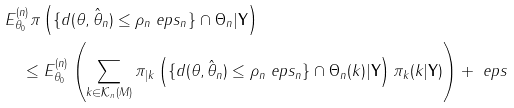Convert formula to latex. <formula><loc_0><loc_0><loc_500><loc_500>& E _ { \theta _ { 0 } } ^ { ( n ) } \pi \left ( \{ d ( \theta , \hat { \theta } _ { n } ) \leq \rho _ { n } \ e p s _ { n } \} \cap \Theta _ { n } | \mathbf Y \right ) \\ & \quad \leq E _ { \theta _ { 0 } } ^ { ( n ) } \left ( \sum _ { k \in \mathcal { K } _ { n } ( M ) } \pi _ { | k } \left ( \{ d ( \theta , \hat { \theta } _ { n } ) \leq \rho _ { n } \ e p s _ { n } \} \cap \Theta _ { n } ( k ) | \mathbf Y \right ) \pi _ { k } ( k | \mathbf Y ) \right ) + \ e p s</formula> 